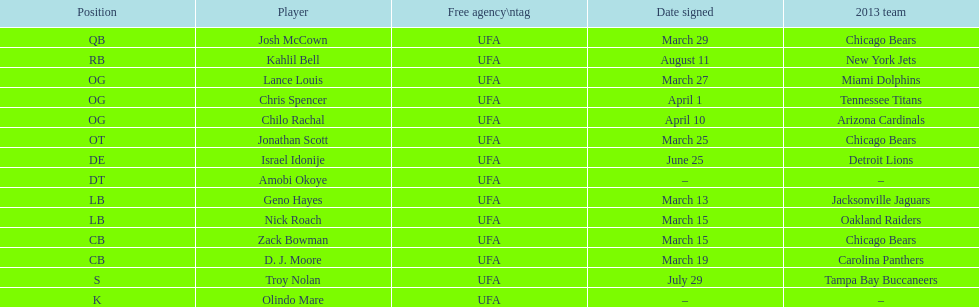In this chart, what is the most frequently played position? OG. 